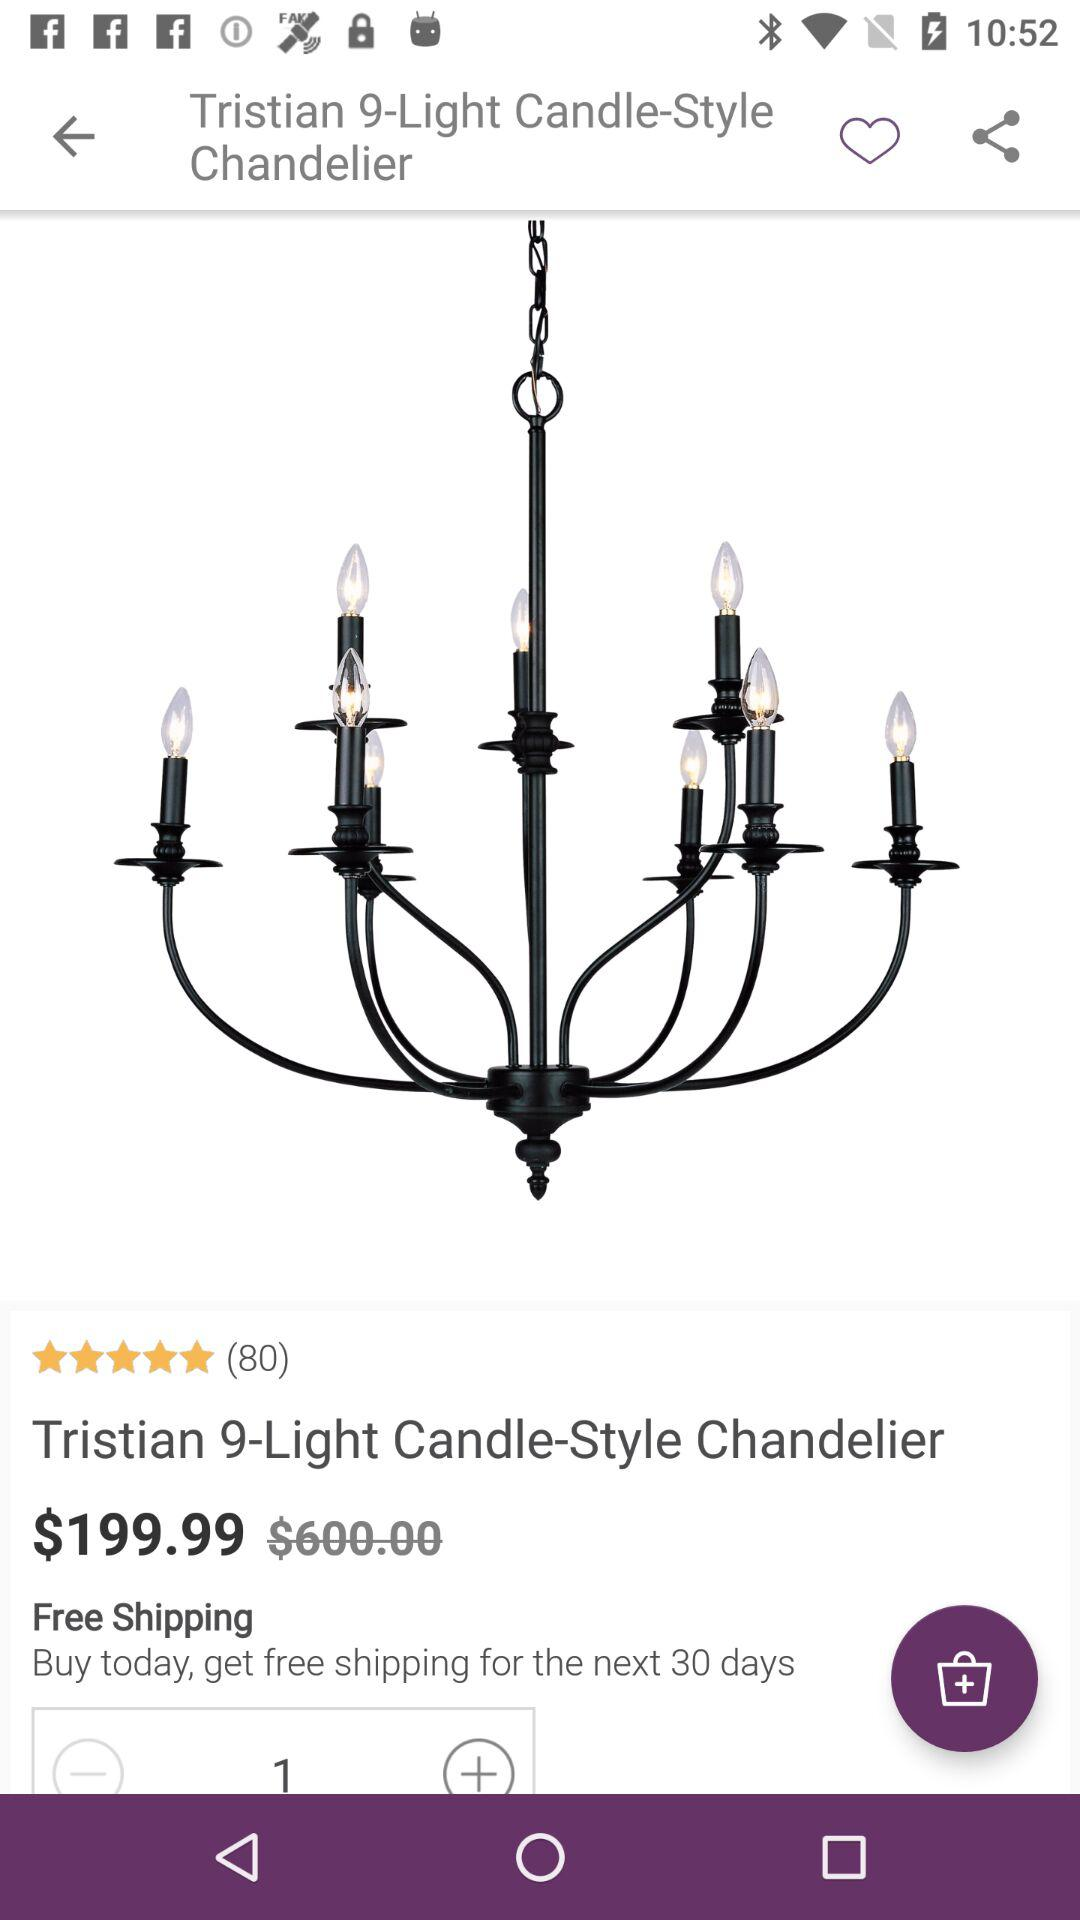Is shipping free or paid?
Answer the question using a single word or phrase. Shipping is free. 